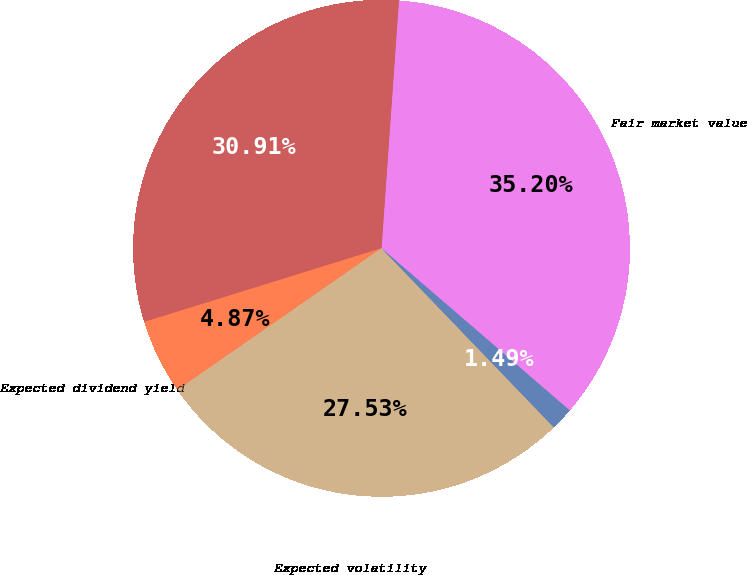Convert chart. <chart><loc_0><loc_0><loc_500><loc_500><pie_chart><fcel>Fair market value<fcel>Option price<fcel>Expected dividend yield<fcel>Expected volatility<fcel>Risk free interest rate<nl><fcel>35.2%<fcel>30.91%<fcel>4.87%<fcel>27.53%<fcel>1.49%<nl></chart> 